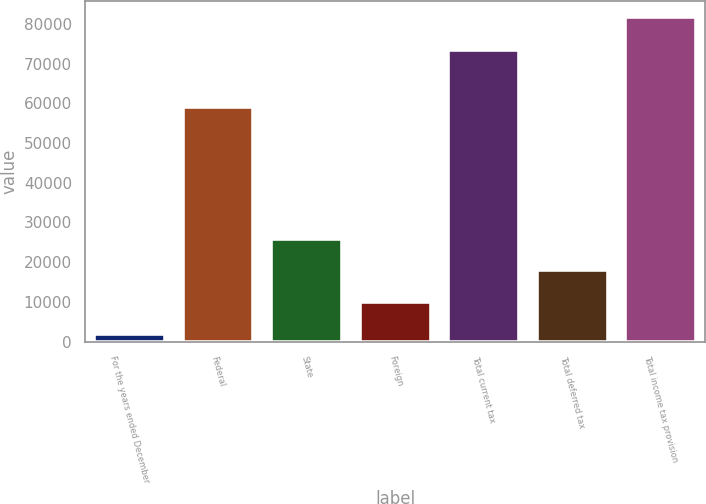Convert chart. <chart><loc_0><loc_0><loc_500><loc_500><bar_chart><fcel>For the years ended December<fcel>Federal<fcel>State<fcel>Foreign<fcel>Total current tax<fcel>Total deferred tax<fcel>Total income tax provision<nl><fcel>2014<fcel>59053<fcel>25955.8<fcel>9994.6<fcel>73380<fcel>17975.2<fcel>81820<nl></chart> 